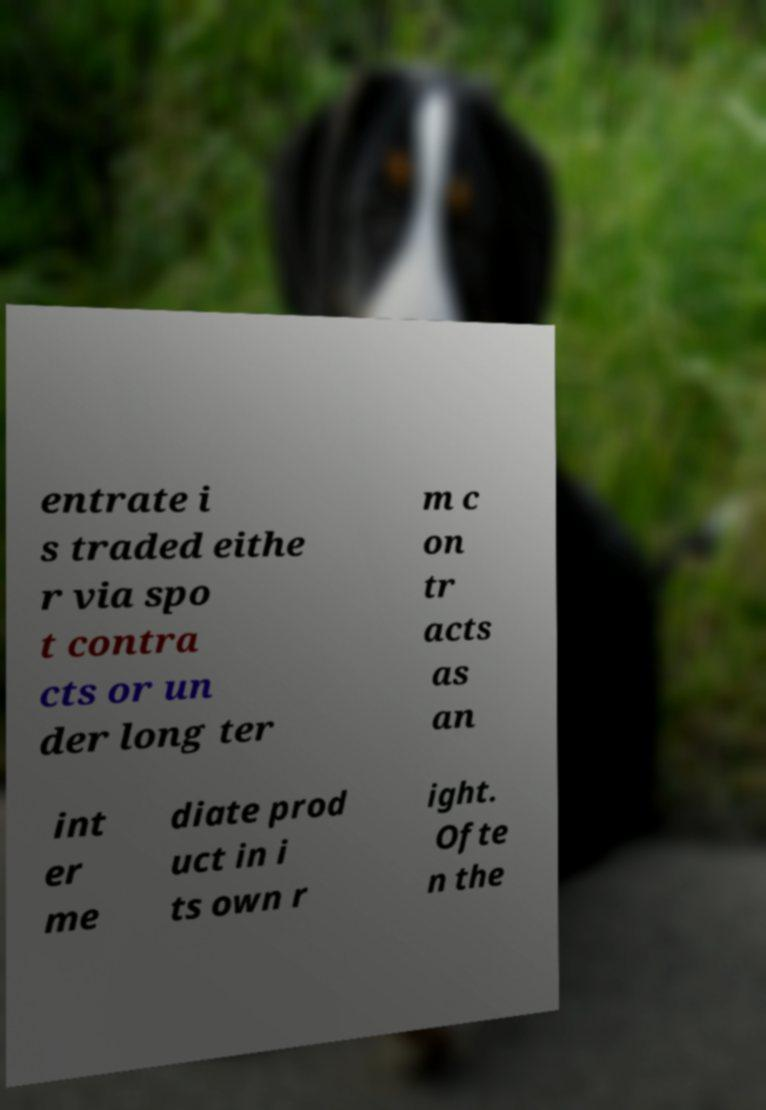There's text embedded in this image that I need extracted. Can you transcribe it verbatim? entrate i s traded eithe r via spo t contra cts or un der long ter m c on tr acts as an int er me diate prod uct in i ts own r ight. Ofte n the 